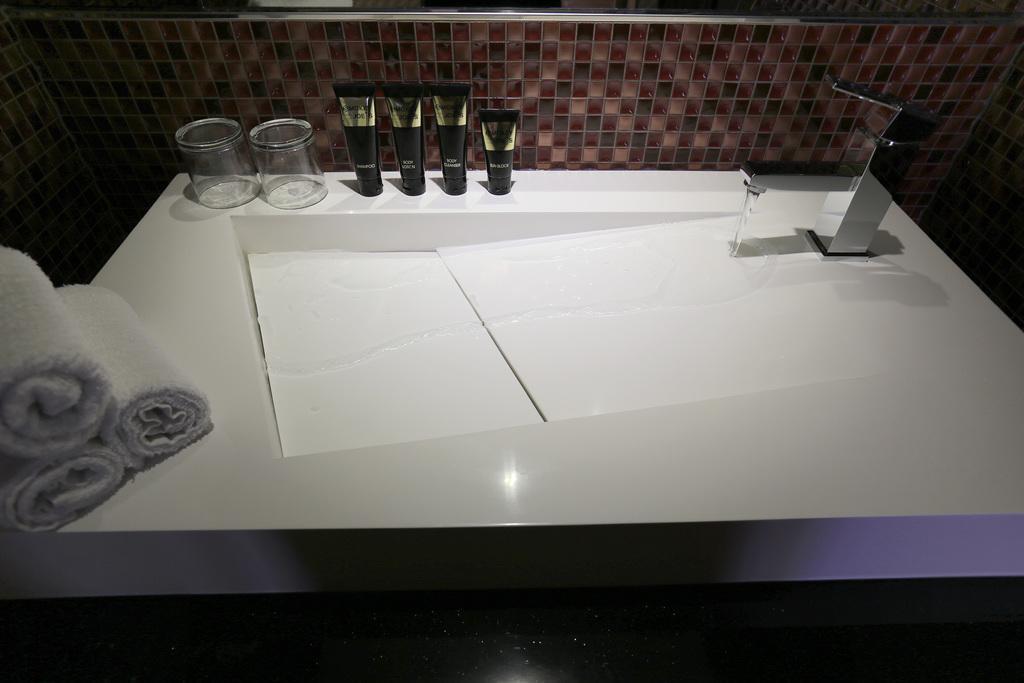Please provide a concise description of this image. In this picture we can see a tap, sink, water and on a white surface we can see glasses, tubes and towels and in the background we can see the wall. 